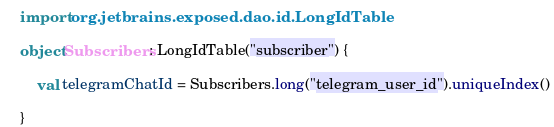<code> <loc_0><loc_0><loc_500><loc_500><_Kotlin_>
import org.jetbrains.exposed.dao.id.LongIdTable

object Subscribers : LongIdTable("subscriber") {

    val telegramChatId = Subscribers.long("telegram_user_id").uniqueIndex()

}</code> 